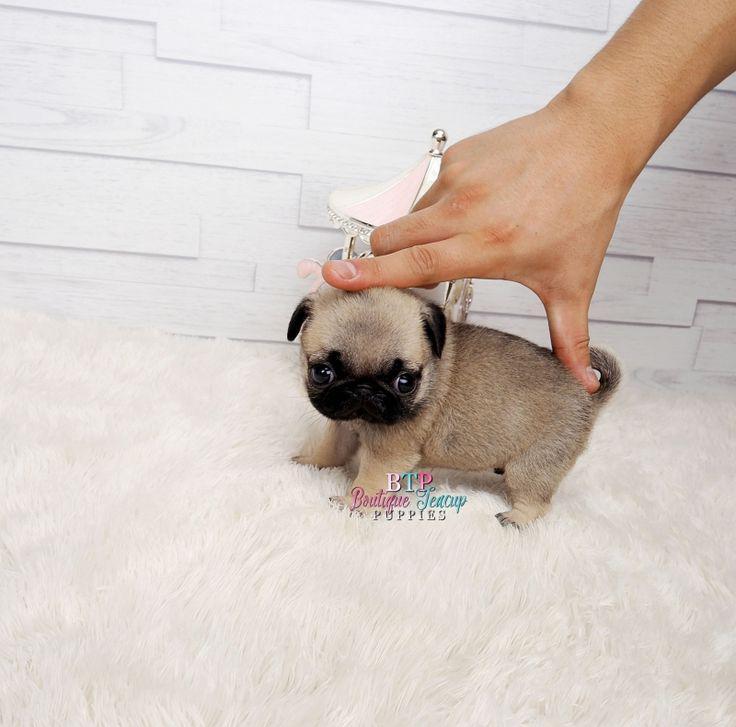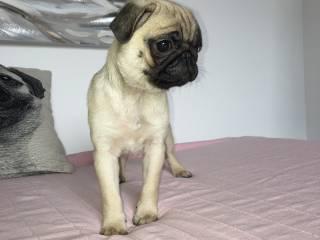The first image is the image on the left, the second image is the image on the right. For the images displayed, is the sentence "A human hand can be seen touching one puppy." factually correct? Answer yes or no. Yes. The first image is the image on the left, the second image is the image on the right. Assess this claim about the two images: "There are atleast 4 pugs total.". Correct or not? Answer yes or no. No. 